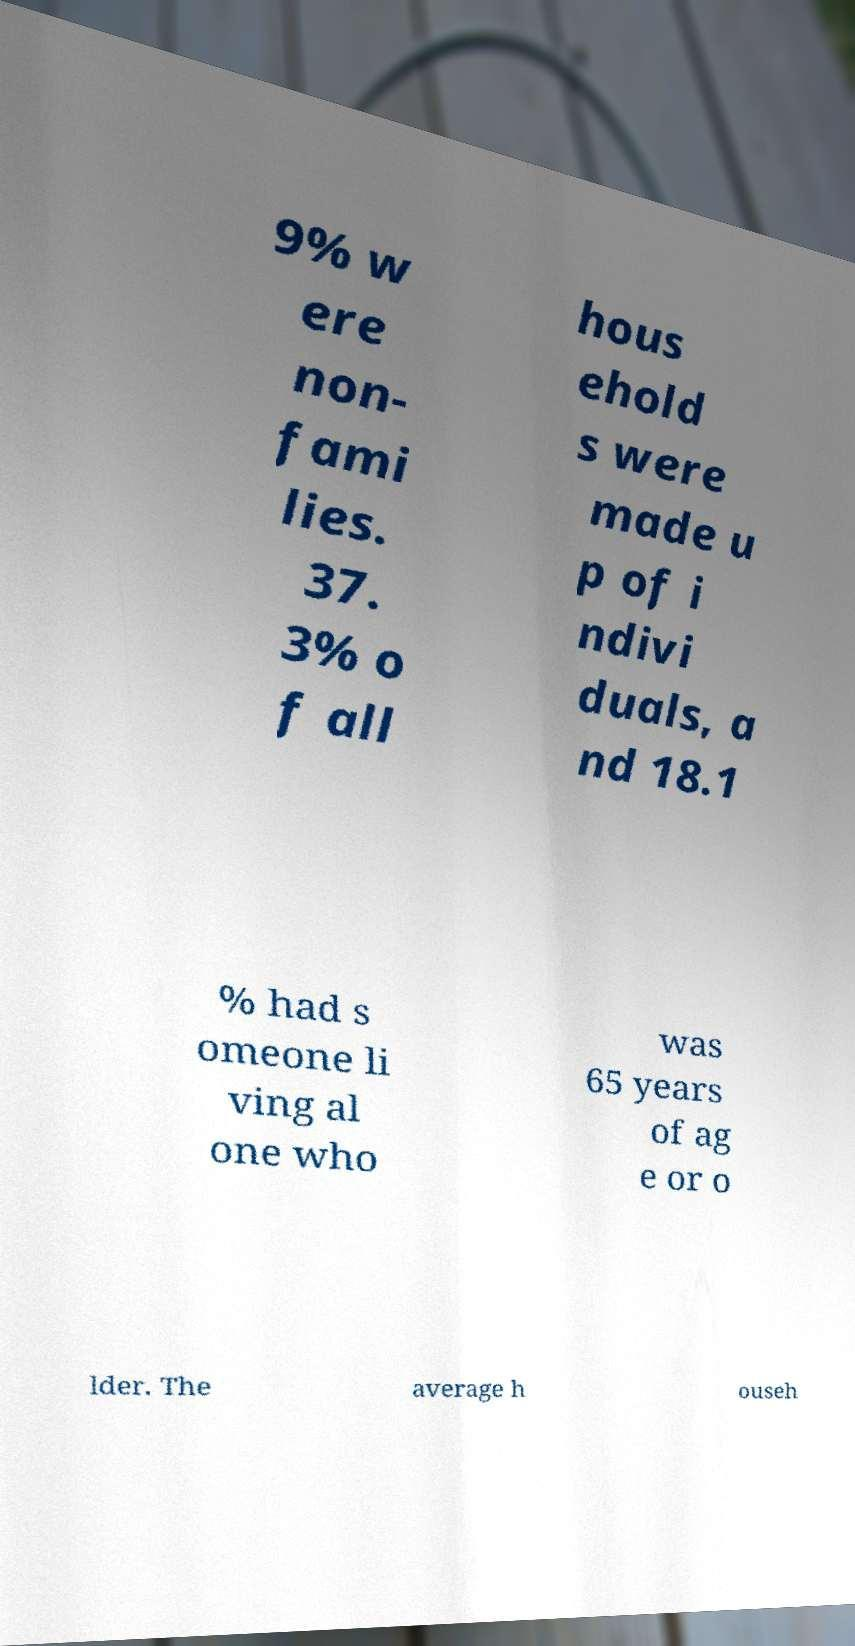Please read and relay the text visible in this image. What does it say? 9% w ere non- fami lies. 37. 3% o f all hous ehold s were made u p of i ndivi duals, a nd 18.1 % had s omeone li ving al one who was 65 years of ag e or o lder. The average h ouseh 